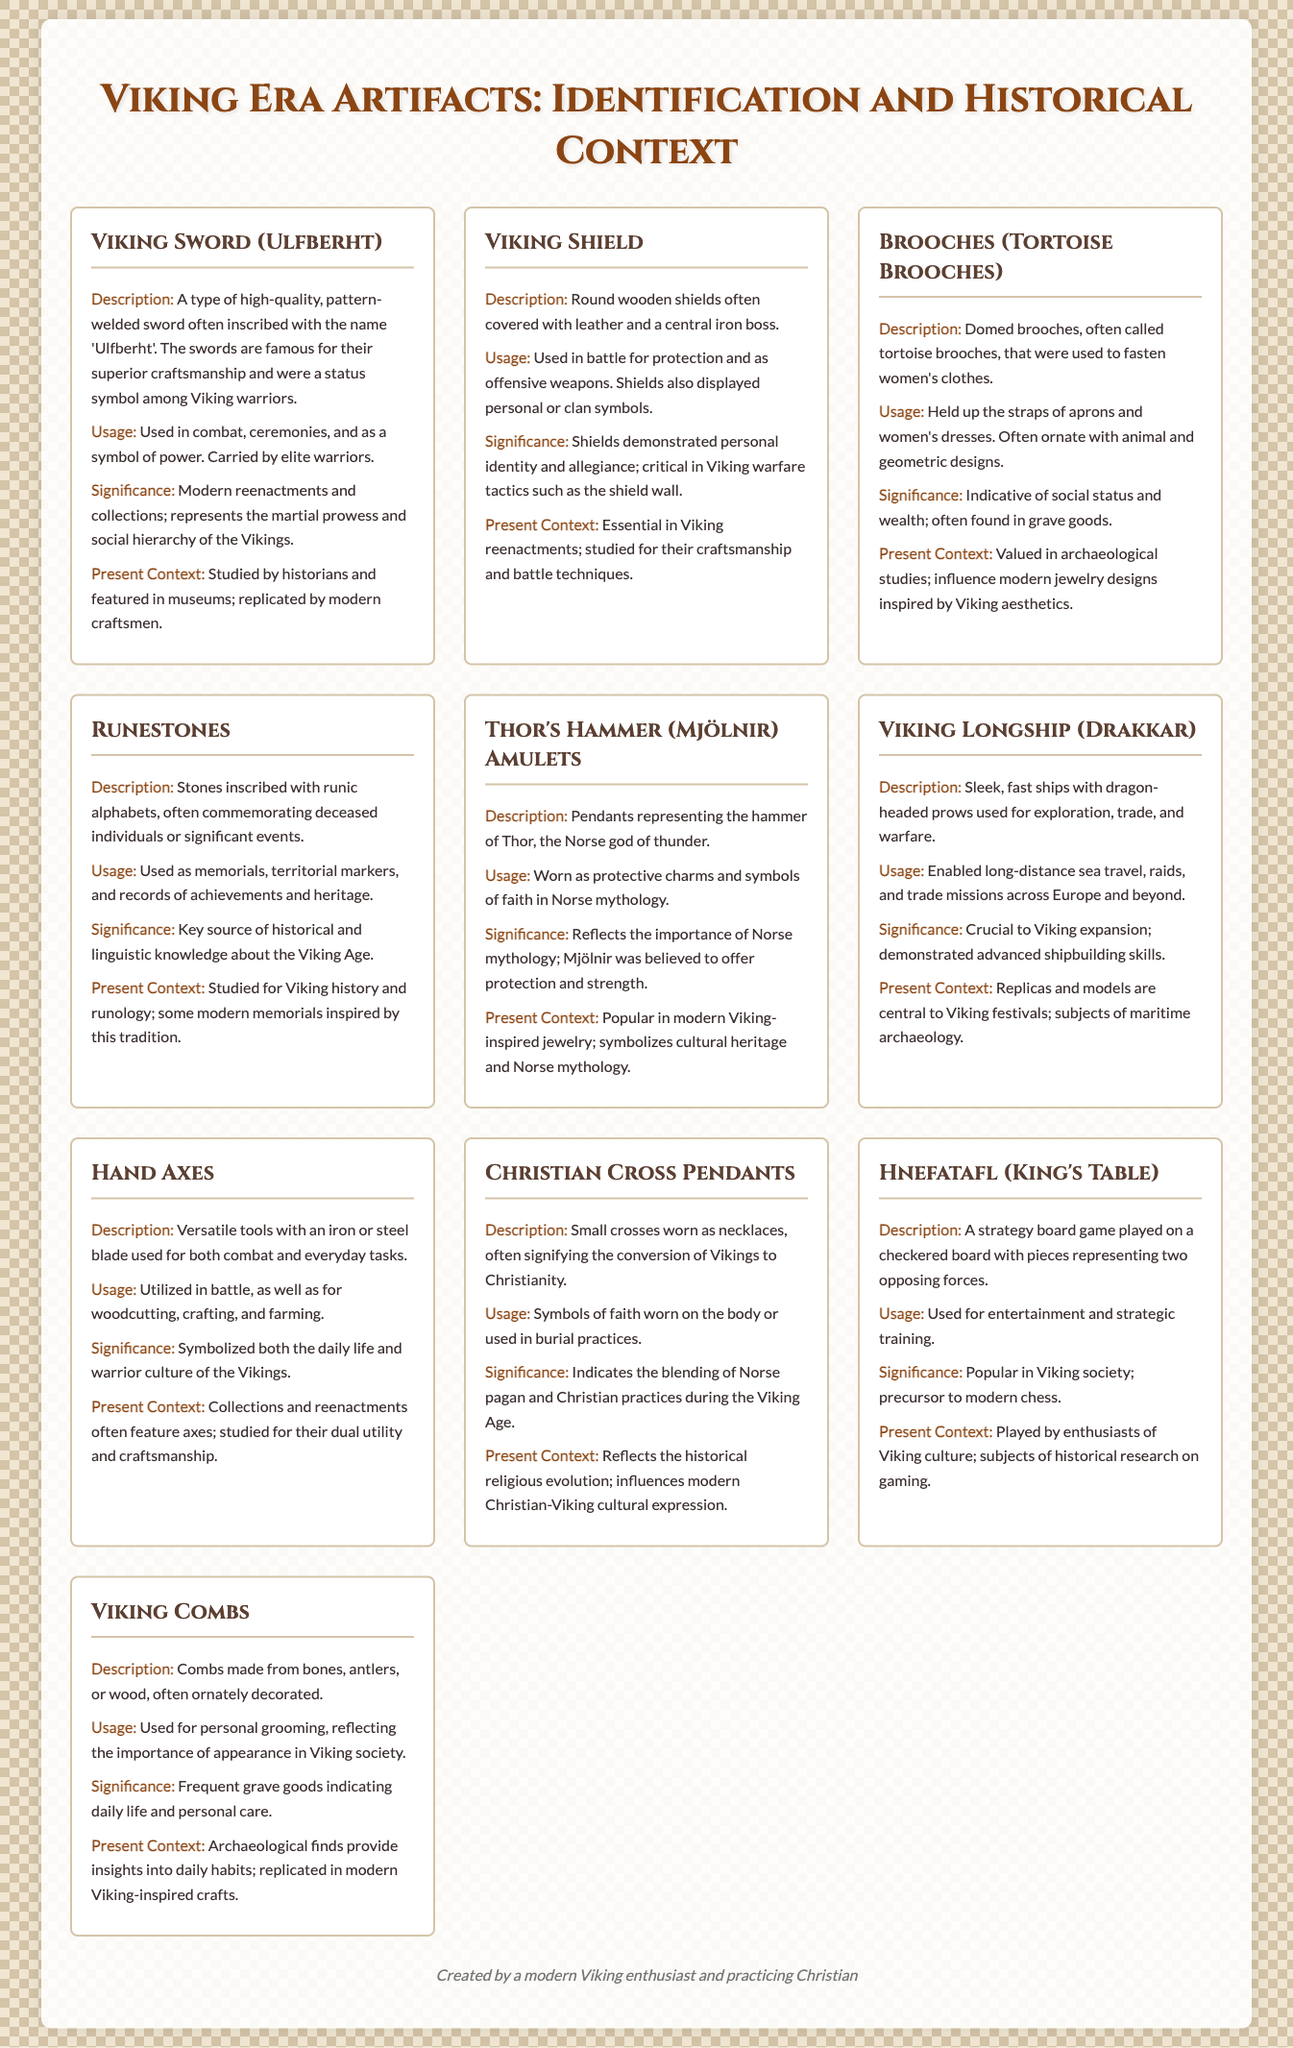what is the name of the high-quality sword often inscribed with 'Ulfberht'? The sword is specifically described as a type of high-quality sword known for its craftsmanship, inscribed with the name 'Ulfberht'.
Answer: Viking Sword (Ulfberht) which artifact was used to fasten women's clothes? The document identifies the tortoise brooches as items that were specifically used to fasten women's clothing.
Answer: Brooches (Tortoise Brooches) what type of amulet represents the hammer of Thor? The document mentions that the pendants representing Thor's hammer are referred to as Mjölnir amulets.
Answer: Thor's Hammer (Mjölnir) Amulets what was the dual purpose of hand axes in Viking society? The document explains that hand axes were used for both combat and everyday tasks, emphasizing their versatility.
Answer: combat and everyday tasks how did Viking shields display personal identity? The document notes that Viking shields displayed personal or clan symbols, which signifies individual identity and allegiance.
Answer: personal or clan symbols what was the usage of runestones in Viking culture? Runestones served multiple purposes, particularly as memorials, territorial markers, and records of achievements and heritage.
Answer: memorials, territorial markers, and records which item is frequently found in grave goods indicating daily life? The document indicates that Viking combs are often found in grave goods, showcasing their importance in daily life.
Answer: Viking Combs what board game is considered a precursor to modern chess? The document refers to the strategy board game Hnefatafl as a precursor to modern chess.
Answer: Hnefatafl (King's Table) 